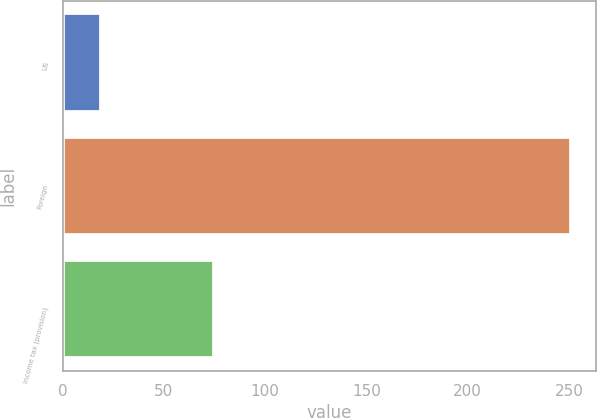<chart> <loc_0><loc_0><loc_500><loc_500><bar_chart><fcel>US<fcel>Foreign<fcel>Income tax (provision)<nl><fcel>19<fcel>251<fcel>75<nl></chart> 